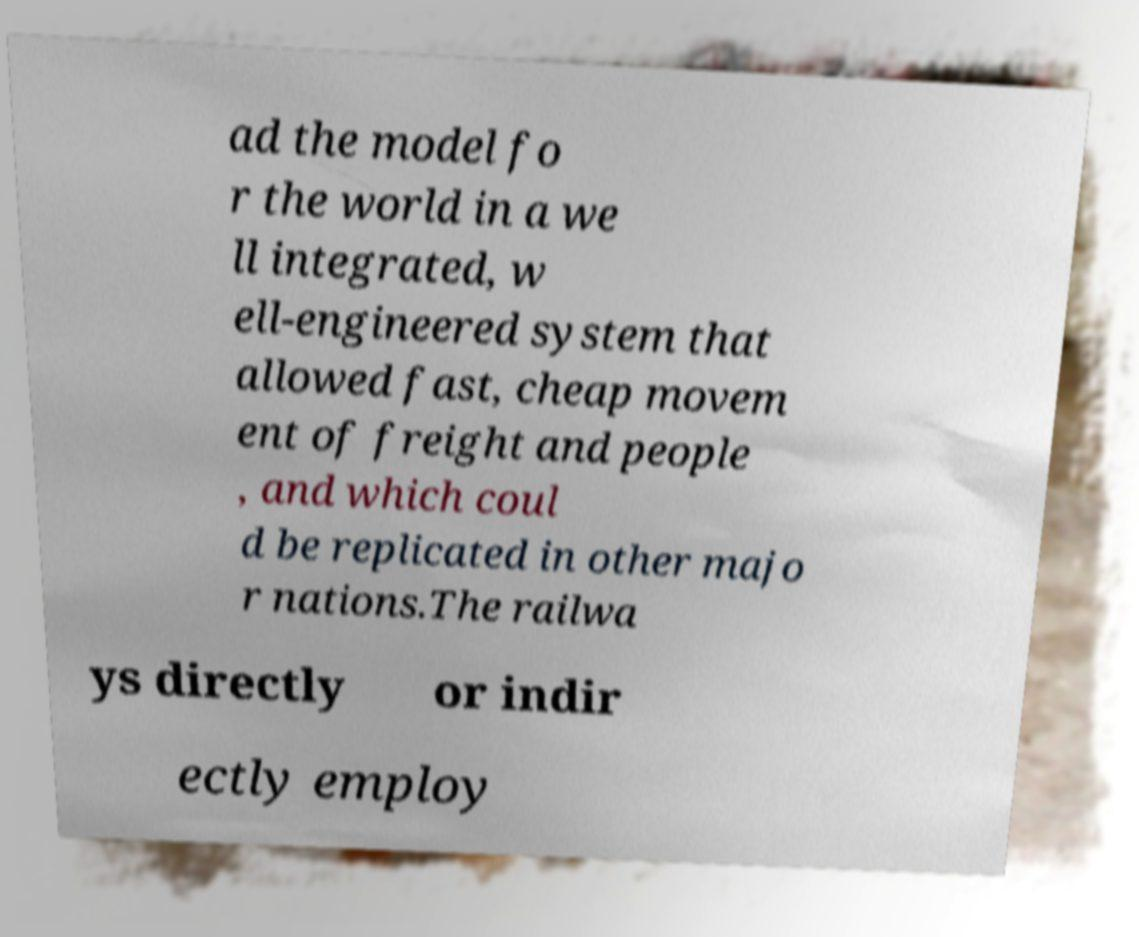I need the written content from this picture converted into text. Can you do that? ad the model fo r the world in a we ll integrated, w ell-engineered system that allowed fast, cheap movem ent of freight and people , and which coul d be replicated in other majo r nations.The railwa ys directly or indir ectly employ 